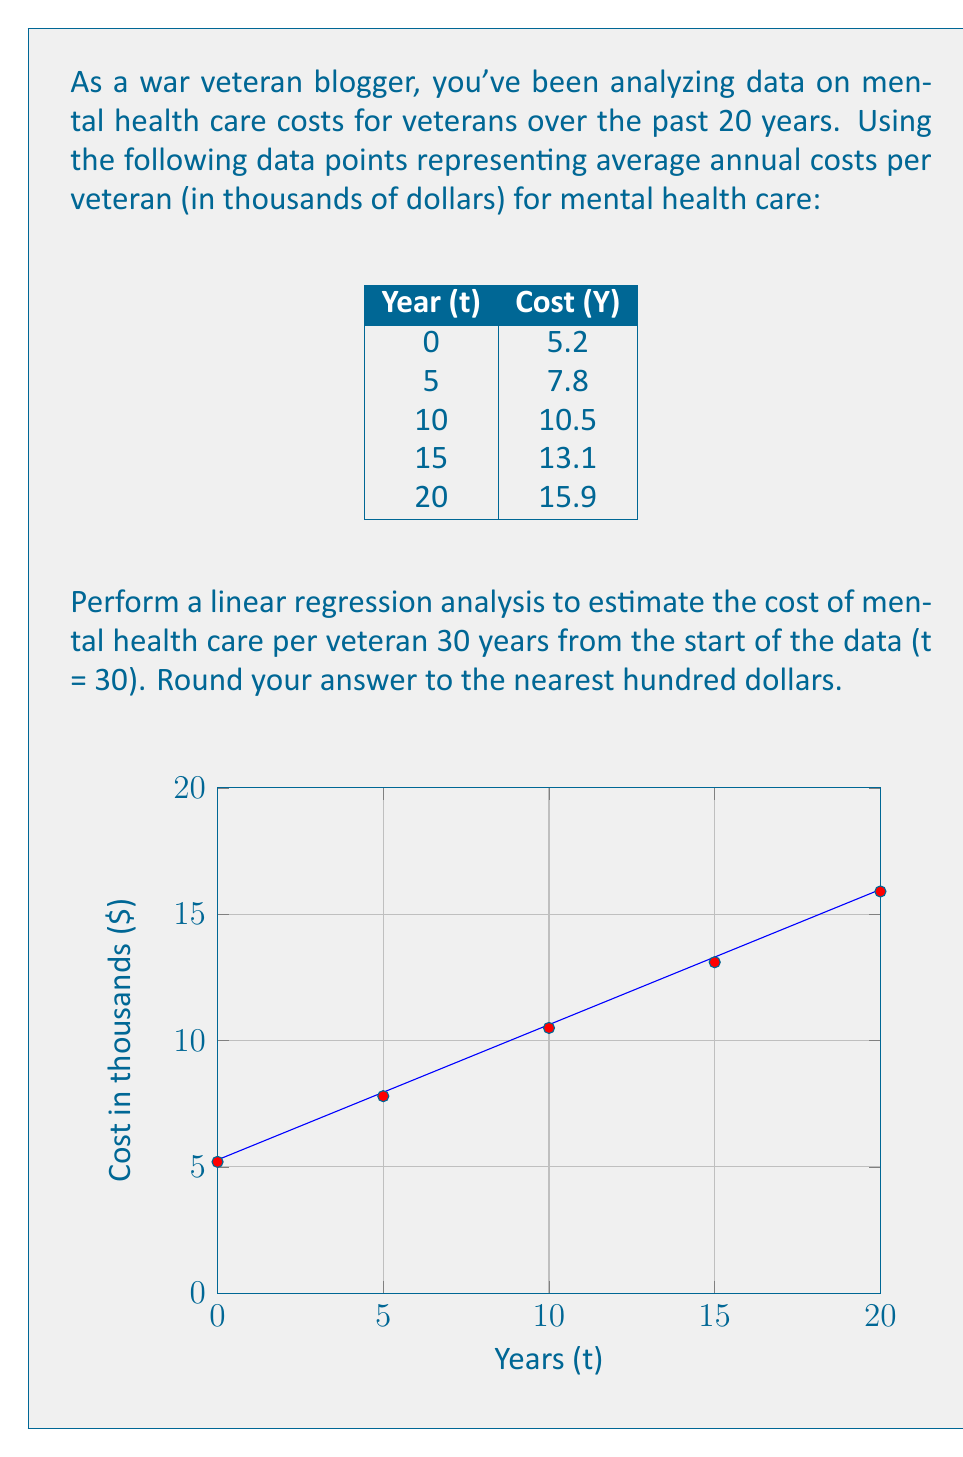Show me your answer to this math problem. To estimate the cost using linear regression, we'll follow these steps:

1) Calculate the means of t and Y:
   $\bar{t} = \frac{0 + 5 + 10 + 15 + 20}{5} = 10$
   $\bar{Y} = \frac{5.2 + 7.8 + 10.5 + 13.1 + 15.9}{5} = 10.5$

2) Calculate $\sum (t - \bar{t})(Y - \bar{Y})$ and $\sum (t - \bar{t})^2$:
   $\sum (t - \bar{t})(Y - \bar{Y}) = (-10)(-5.3) + (-5)(-2.7) + (0)(0) + (5)(2.6) + (10)(5.4) = 132.5$
   $\sum (t - \bar{t})^2 = (-10)^2 + (-5)^2 + 0^2 + 5^2 + 10^2 = 250$

3) Calculate the slope (b) of the regression line:
   $b = \frac{\sum (t - \bar{t})(Y - \bar{Y})}{\sum (t - \bar{t})^2} = \frac{132.5}{250} = 0.53$

4) Calculate the y-intercept (a) using $Y = a + bt$:
   $10.5 = a + 0.53(10)$
   $a = 10.5 - 5.3 = 5.2$

5) The regression equation is:
   $Y = 5.2 + 0.53t$

6) To estimate the cost at t = 30:
   $Y = 5.2 + 0.53(30) = 21.1$

Therefore, the estimated cost per veteran for mental health care after 30 years is $21,100.
Answer: $21,100 